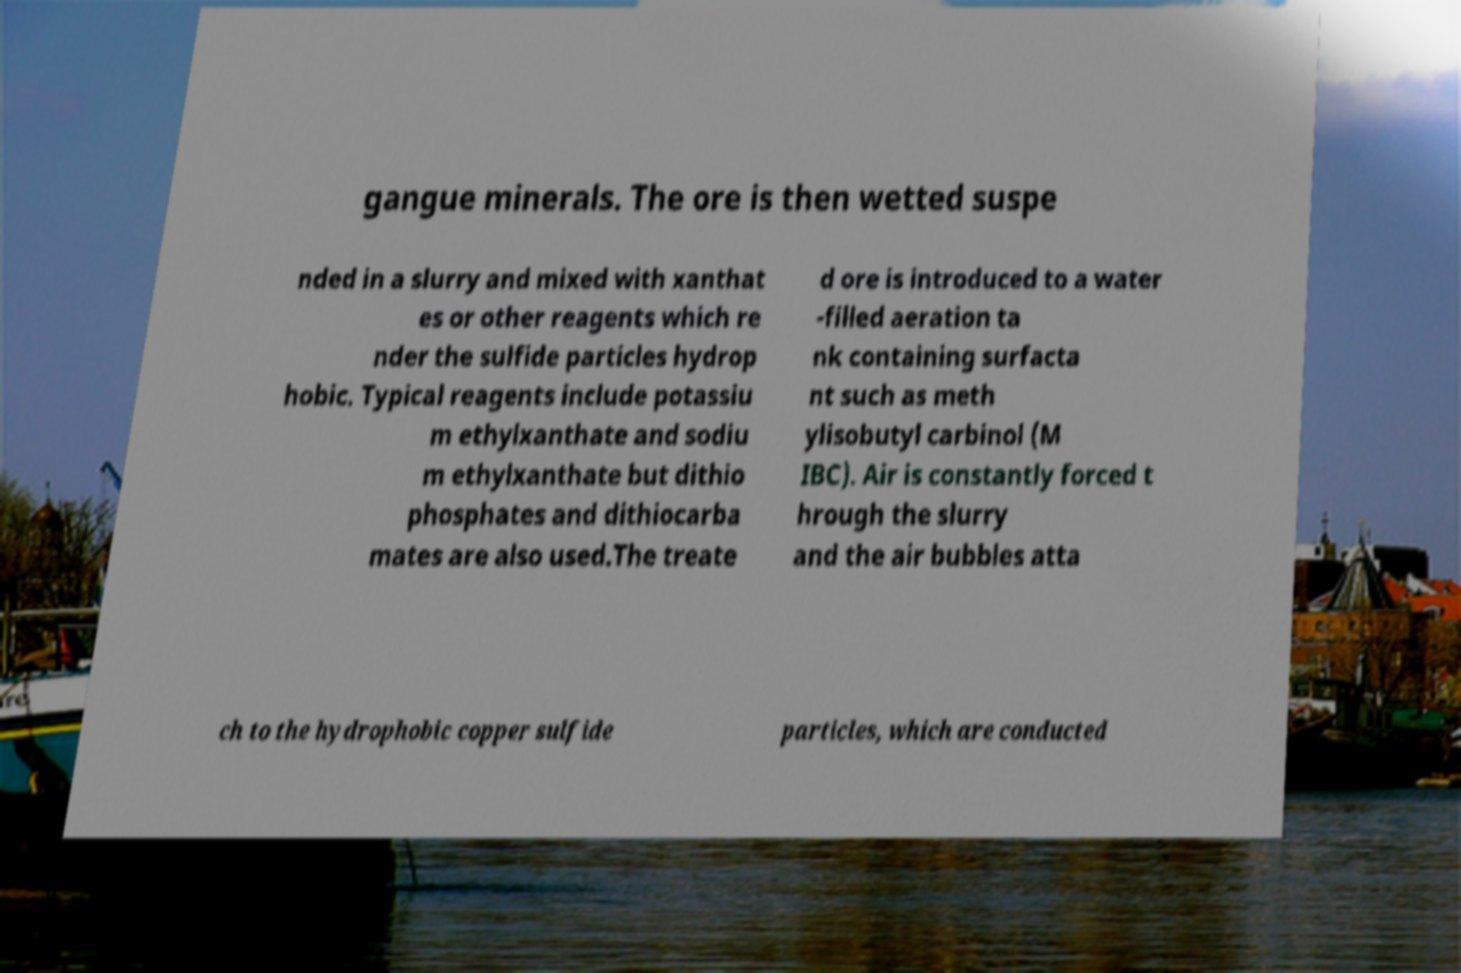Could you assist in decoding the text presented in this image and type it out clearly? gangue minerals. The ore is then wetted suspe nded in a slurry and mixed with xanthat es or other reagents which re nder the sulfide particles hydrop hobic. Typical reagents include potassiu m ethylxanthate and sodiu m ethylxanthate but dithio phosphates and dithiocarba mates are also used.The treate d ore is introduced to a water -filled aeration ta nk containing surfacta nt such as meth ylisobutyl carbinol (M IBC). Air is constantly forced t hrough the slurry and the air bubbles atta ch to the hydrophobic copper sulfide particles, which are conducted 